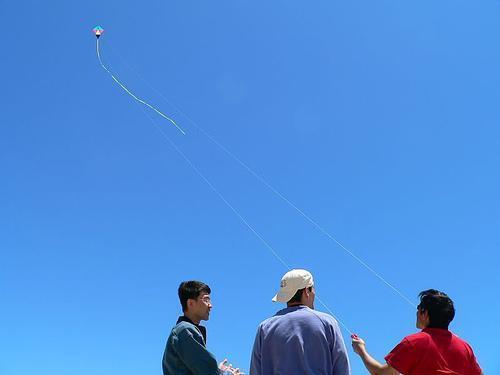How many kites in the air?
Give a very brief answer. 1. How many people are there?
Give a very brief answer. 3. 